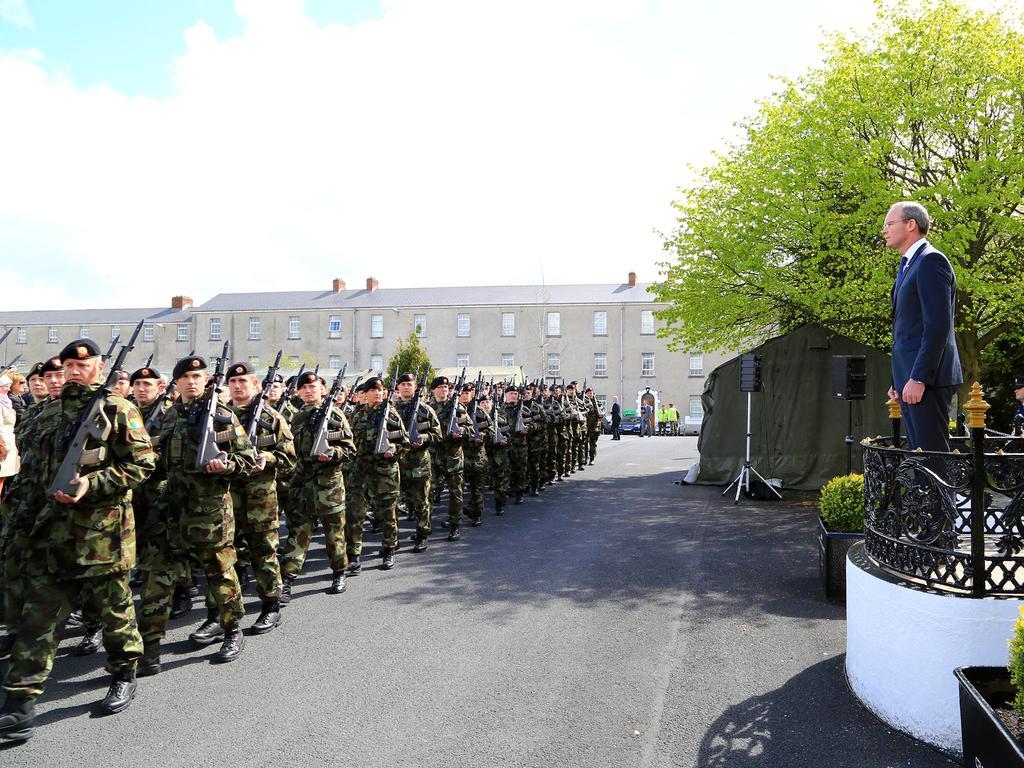Please provide a concise description of this image. Here we can see group of people are walking on the road and there is a person standing on the floor. Here we can see plants, fence, speakers, tent, vehicles, and trees. In the background there are buildings and sky with clouds. 